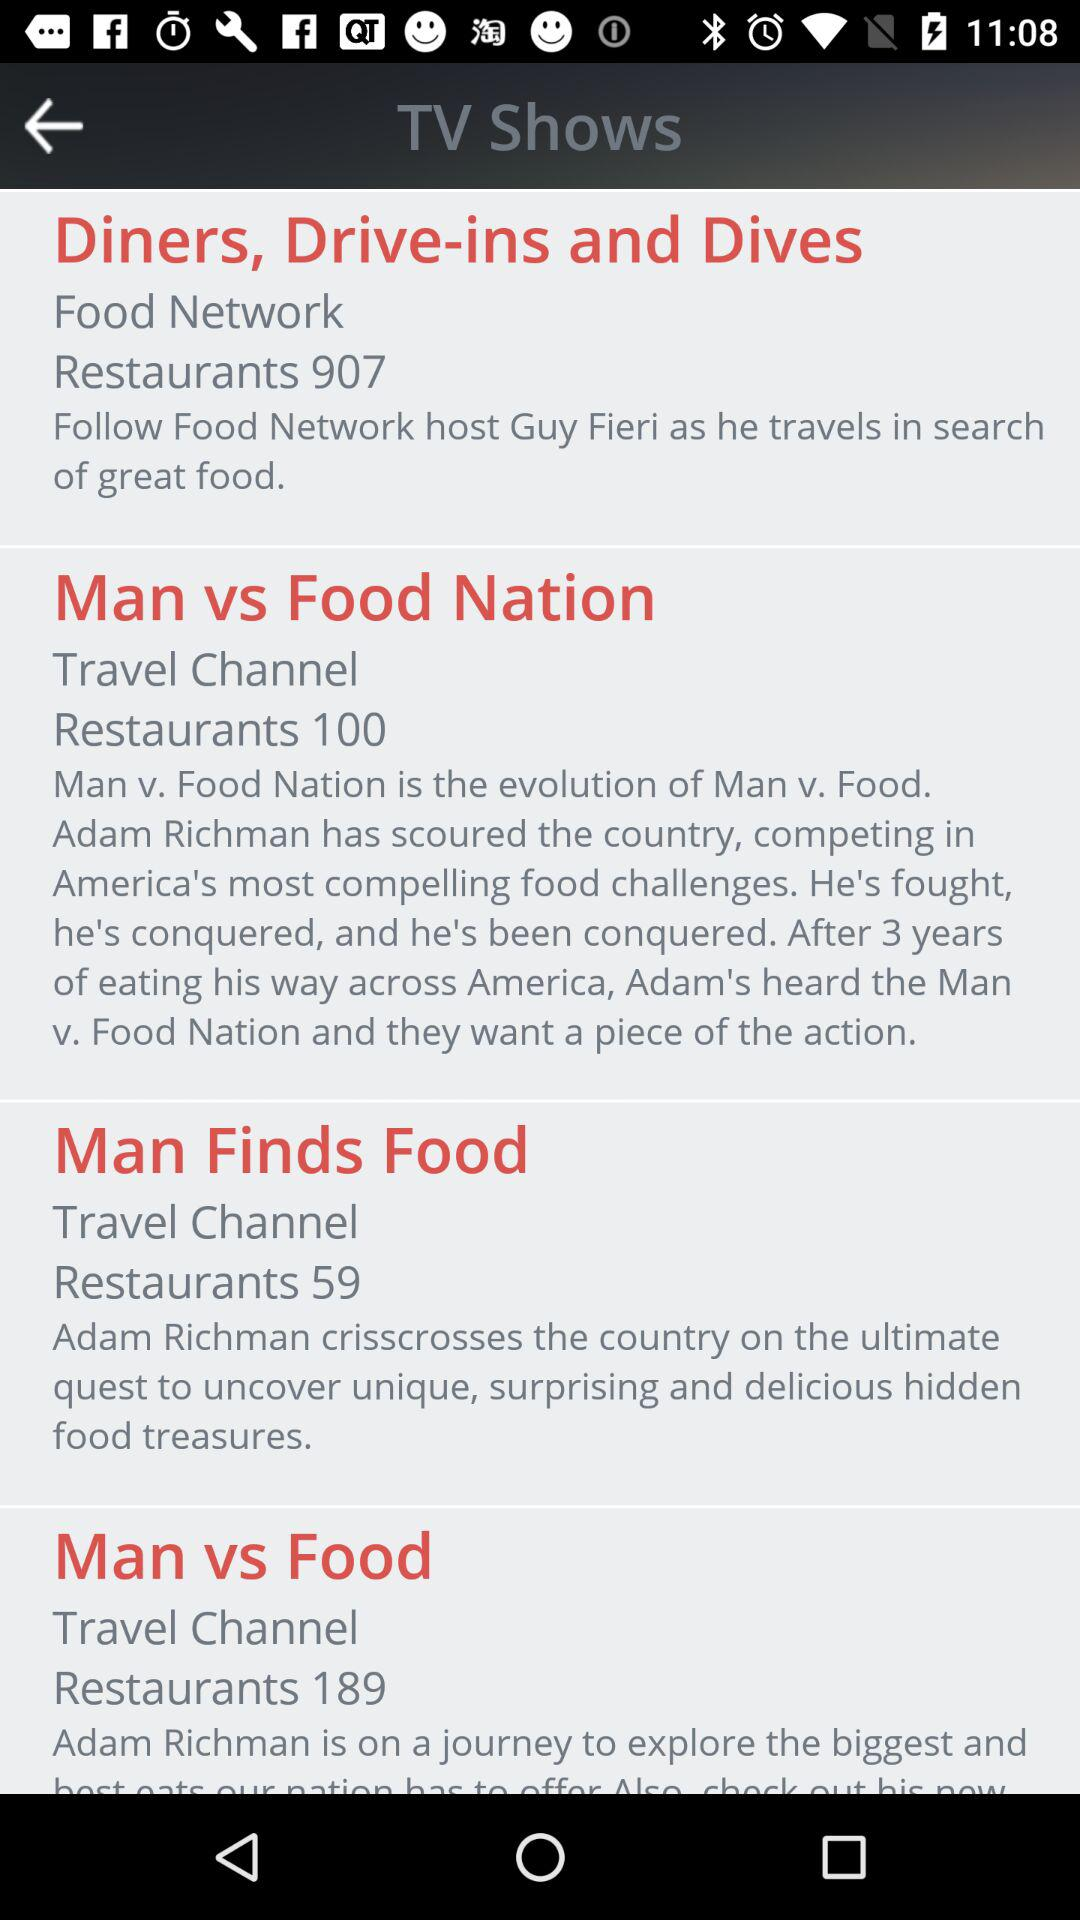How many more shows are on the Travel Channel than the Food Network?
Answer the question using a single word or phrase. 2 